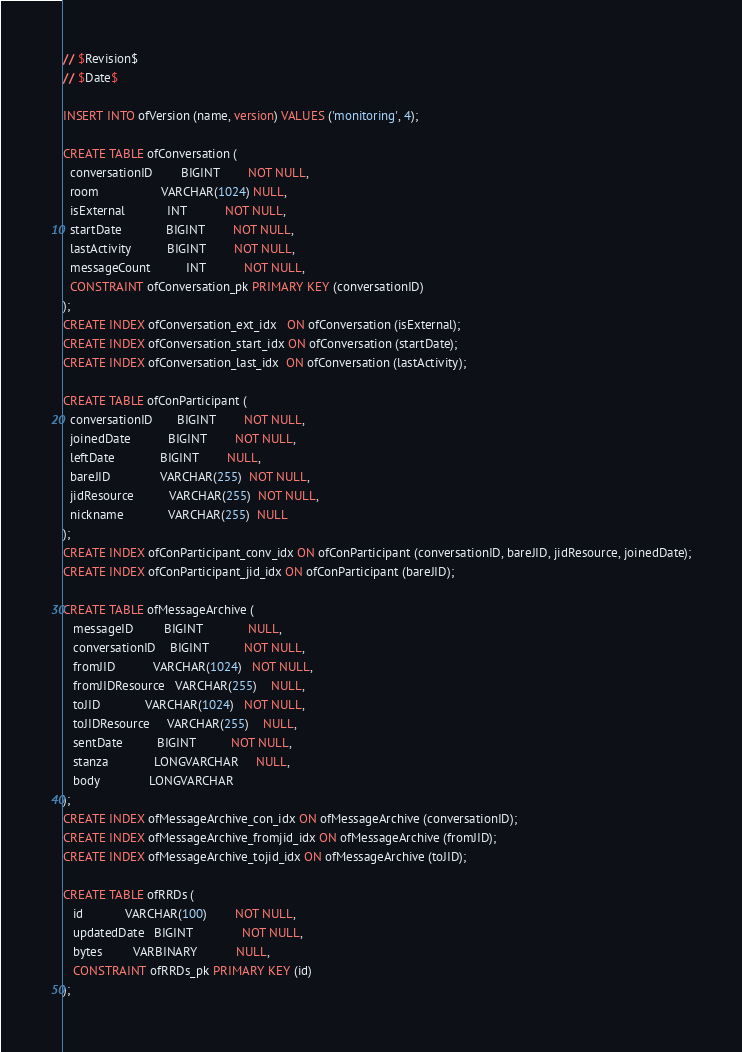<code> <loc_0><loc_0><loc_500><loc_500><_SQL_>// $Revision$
// $Date$

INSERT INTO ofVersion (name, version) VALUES ('monitoring', 4);

CREATE TABLE ofConversation (
  conversationID        BIGINT        NOT NULL,
  room                  VARCHAR(1024) NULL,
  isExternal            INT           NOT NULL,
  startDate             BIGINT        NOT NULL,
  lastActivity          BIGINT        NOT NULL,
  messageCount          INT           NOT NULL,
  CONSTRAINT ofConversation_pk PRIMARY KEY (conversationID)
);
CREATE INDEX ofConversation_ext_idx   ON ofConversation (isExternal);
CREATE INDEX ofConversation_start_idx ON ofConversation (startDate);
CREATE INDEX ofConversation_last_idx  ON ofConversation (lastActivity);

CREATE TABLE ofConParticipant (
  conversationID       BIGINT        NOT NULL,
  joinedDate           BIGINT        NOT NULL,
  leftDate             BIGINT        NULL,
  bareJID              VARCHAR(255)  NOT NULL,
  jidResource          VARCHAR(255)  NOT NULL,
  nickname             VARCHAR(255)  NULL
);
CREATE INDEX ofConParticipant_conv_idx ON ofConParticipant (conversationID, bareJID, jidResource, joinedDate);
CREATE INDEX ofConParticipant_jid_idx ON ofConParticipant (bareJID);

CREATE TABLE ofMessageArchive (
   messageID		 BIGINT			 NULL,
   conversationID    BIGINT          NOT NULL,
   fromJID           VARCHAR(1024)   NOT NULL,
   fromJIDResource   VARCHAR(255)    NULL,
   toJID             VARCHAR(1024)   NOT NULL,
   toJIDResource     VARCHAR(255)    NULL,
   sentDate          BIGINT          NOT NULL,
   stanza			 LONGVARCHAR	 NULL,
   body              LONGVARCHAR
);
CREATE INDEX ofMessageArchive_con_idx ON ofMessageArchive (conversationID);
CREATE INDEX ofMessageArchive_fromjid_idx ON ofMessageArchive (fromJID);
CREATE INDEX ofMessageArchive_tojid_idx ON ofMessageArchive (toJID);

CREATE TABLE ofRRDs (
   id            VARCHAR(100)        NOT NULL,
   updatedDate   BIGINT              NOT NULL,
   bytes         VARBINARY           NULL,
   CONSTRAINT ofRRDs_pk PRIMARY KEY (id)
);

</code> 